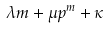Convert formula to latex. <formula><loc_0><loc_0><loc_500><loc_500>\lambda m + \mu p ^ { m } + \kappa</formula> 